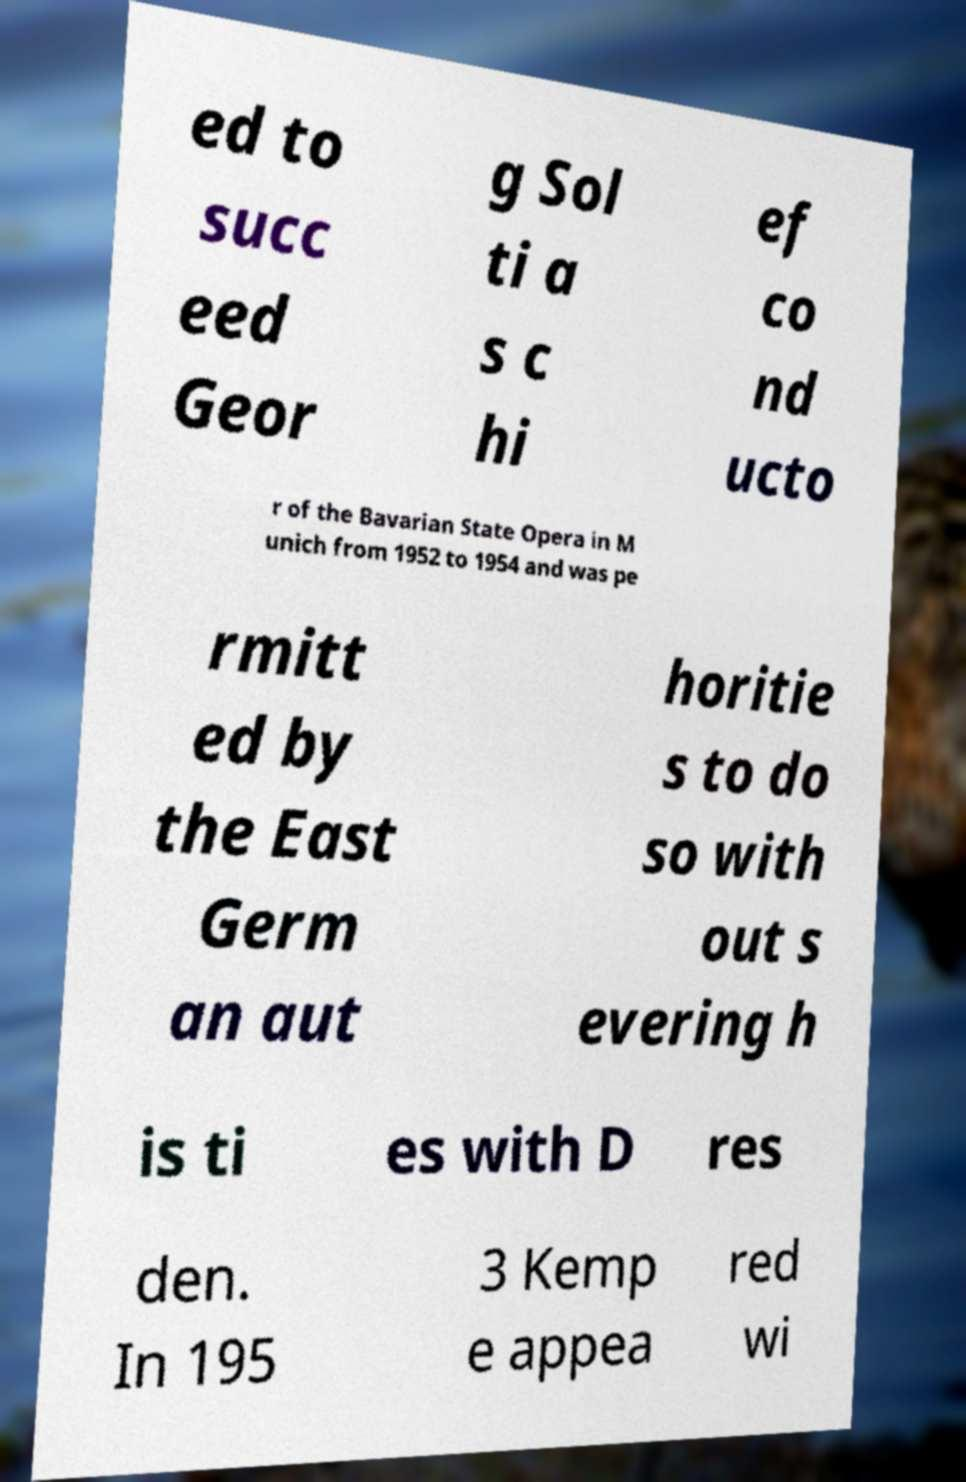What messages or text are displayed in this image? I need them in a readable, typed format. ed to succ eed Geor g Sol ti a s c hi ef co nd ucto r of the Bavarian State Opera in M unich from 1952 to 1954 and was pe rmitt ed by the East Germ an aut horitie s to do so with out s evering h is ti es with D res den. In 195 3 Kemp e appea red wi 